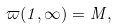Convert formula to latex. <formula><loc_0><loc_0><loc_500><loc_500>\varpi ( 1 , \infty ) = M ,</formula> 